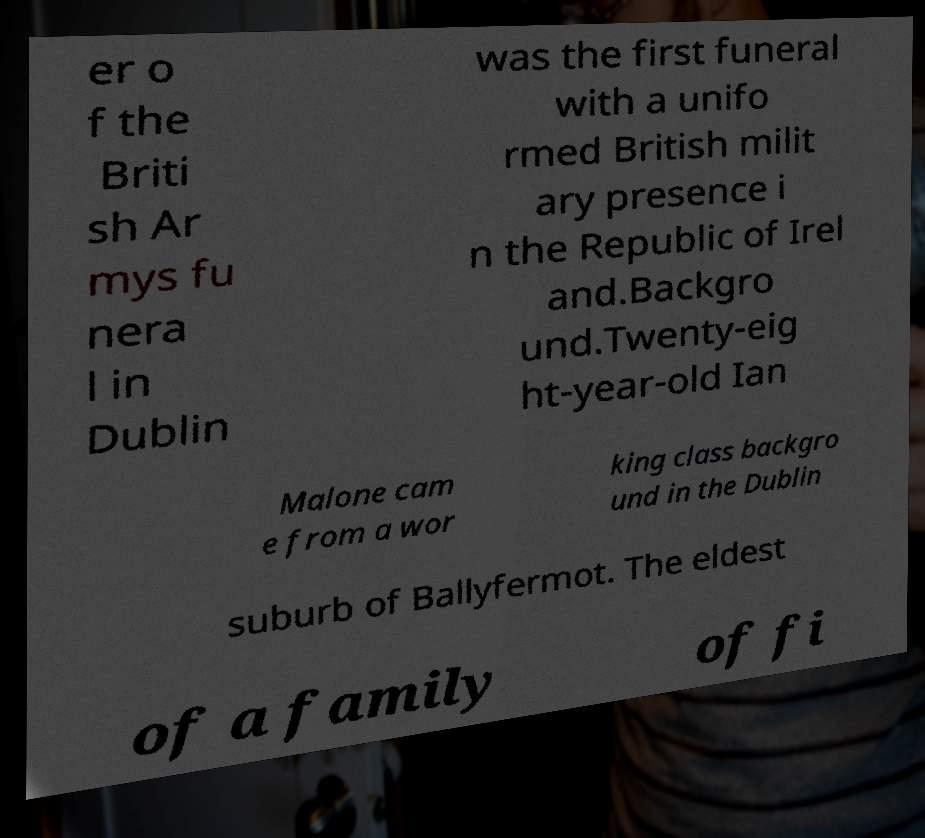Can you accurately transcribe the text from the provided image for me? er o f the Briti sh Ar mys fu nera l in Dublin was the first funeral with a unifo rmed British milit ary presence i n the Republic of Irel and.Backgro und.Twenty-eig ht-year-old Ian Malone cam e from a wor king class backgro und in the Dublin suburb of Ballyfermot. The eldest of a family of fi 